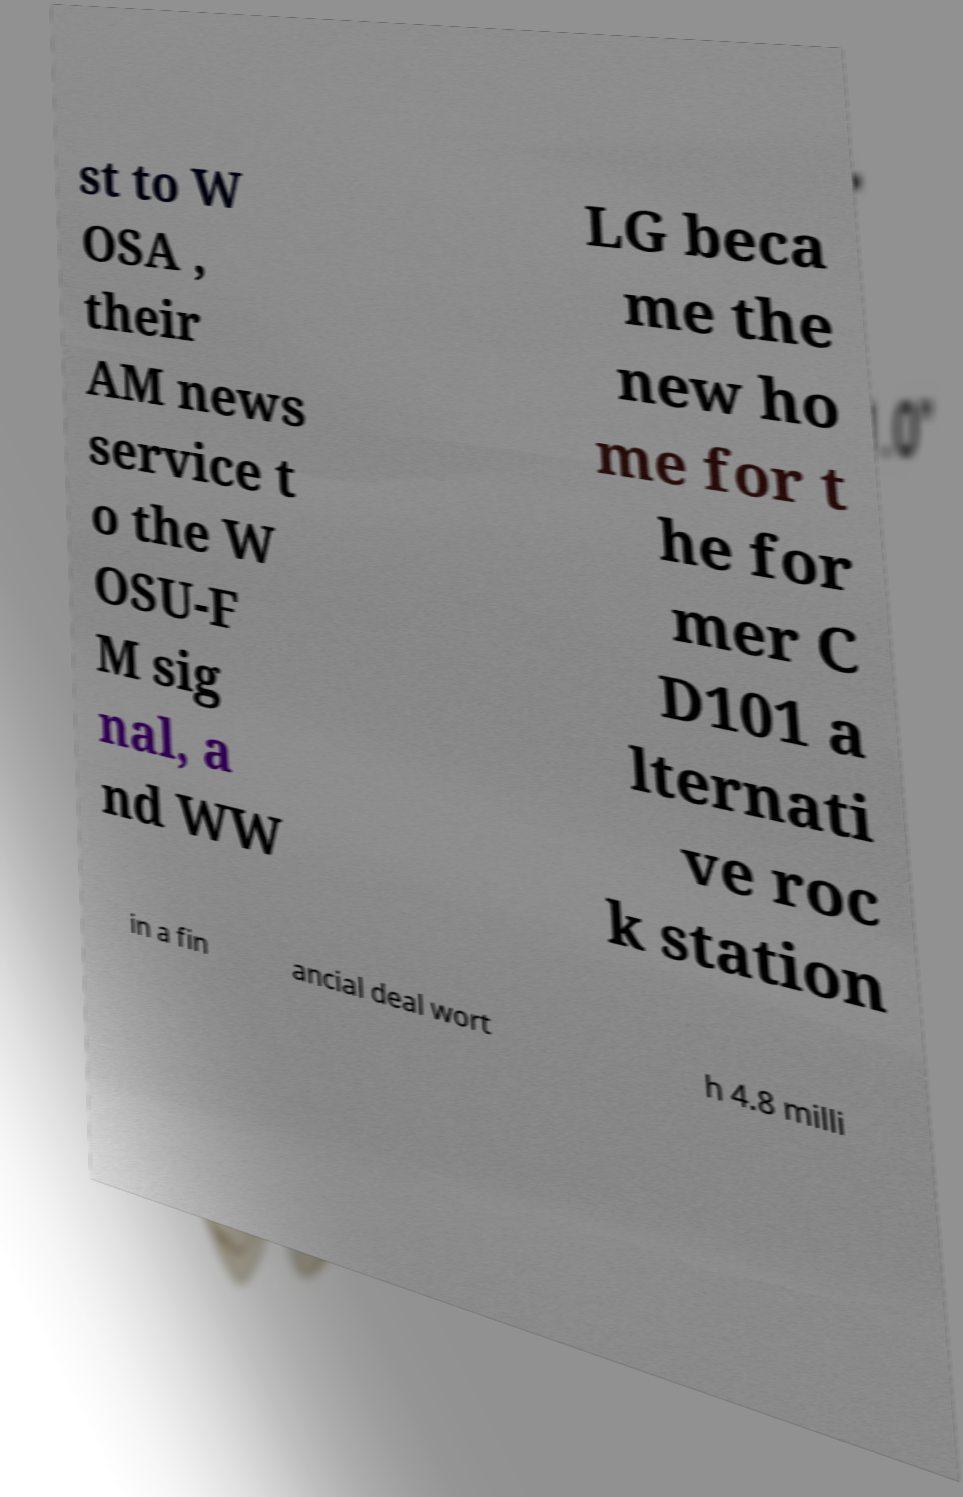There's text embedded in this image that I need extracted. Can you transcribe it verbatim? st to W OSA , their AM news service t o the W OSU-F M sig nal, a nd WW LG beca me the new ho me for t he for mer C D101 a lternati ve roc k station in a fin ancial deal wort h 4.8 milli 